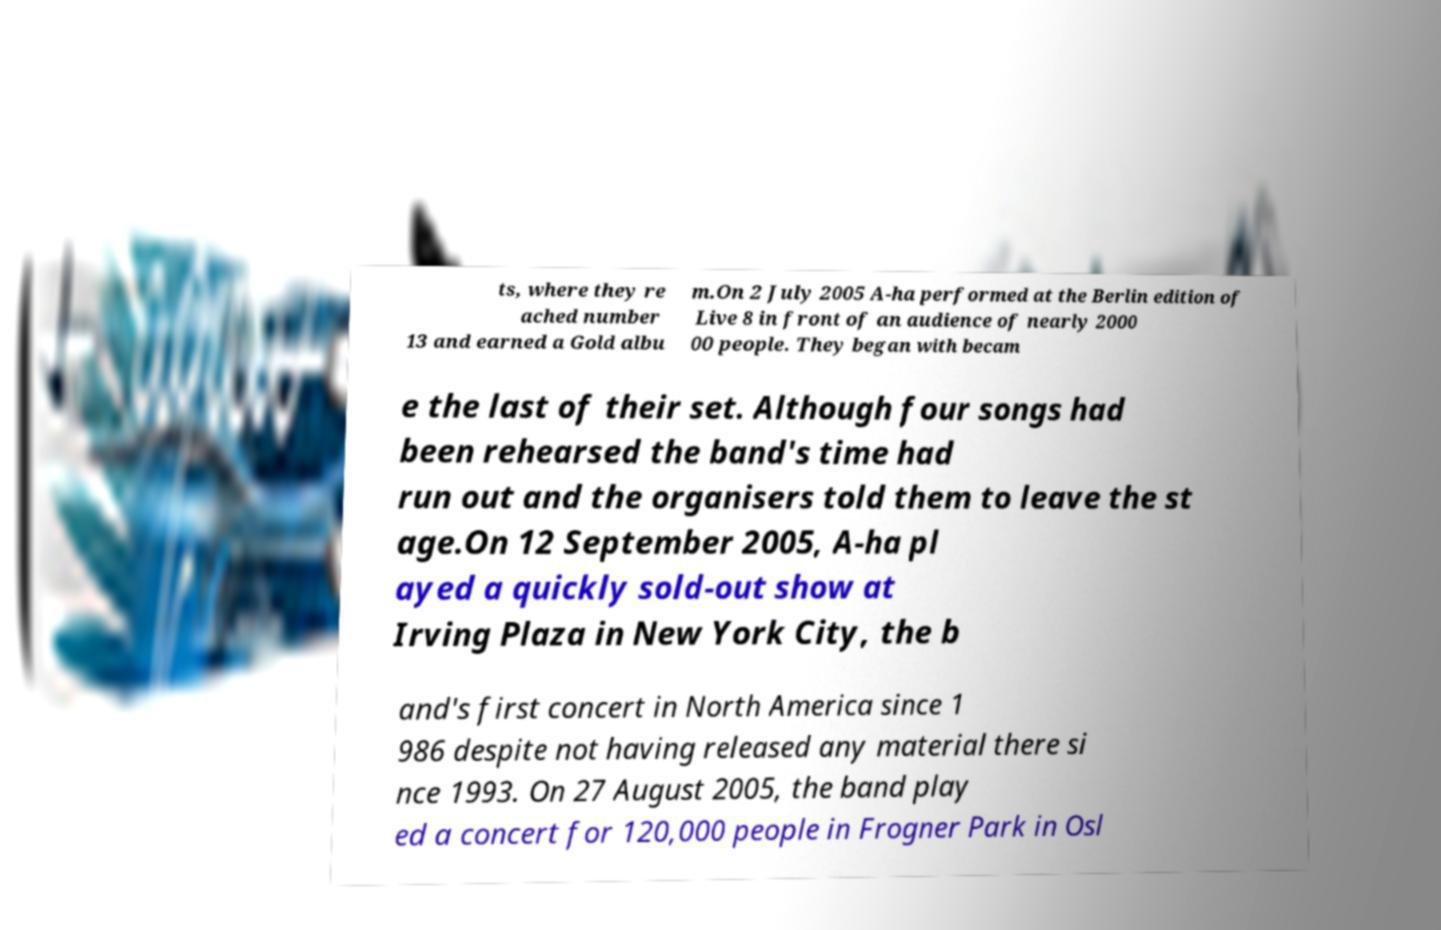Please identify and transcribe the text found in this image. ts, where they re ached number 13 and earned a Gold albu m.On 2 July 2005 A-ha performed at the Berlin edition of Live 8 in front of an audience of nearly 2000 00 people. They began with becam e the last of their set. Although four songs had been rehearsed the band's time had run out and the organisers told them to leave the st age.On 12 September 2005, A-ha pl ayed a quickly sold-out show at Irving Plaza in New York City, the b and's first concert in North America since 1 986 despite not having released any material there si nce 1993. On 27 August 2005, the band play ed a concert for 120,000 people in Frogner Park in Osl 